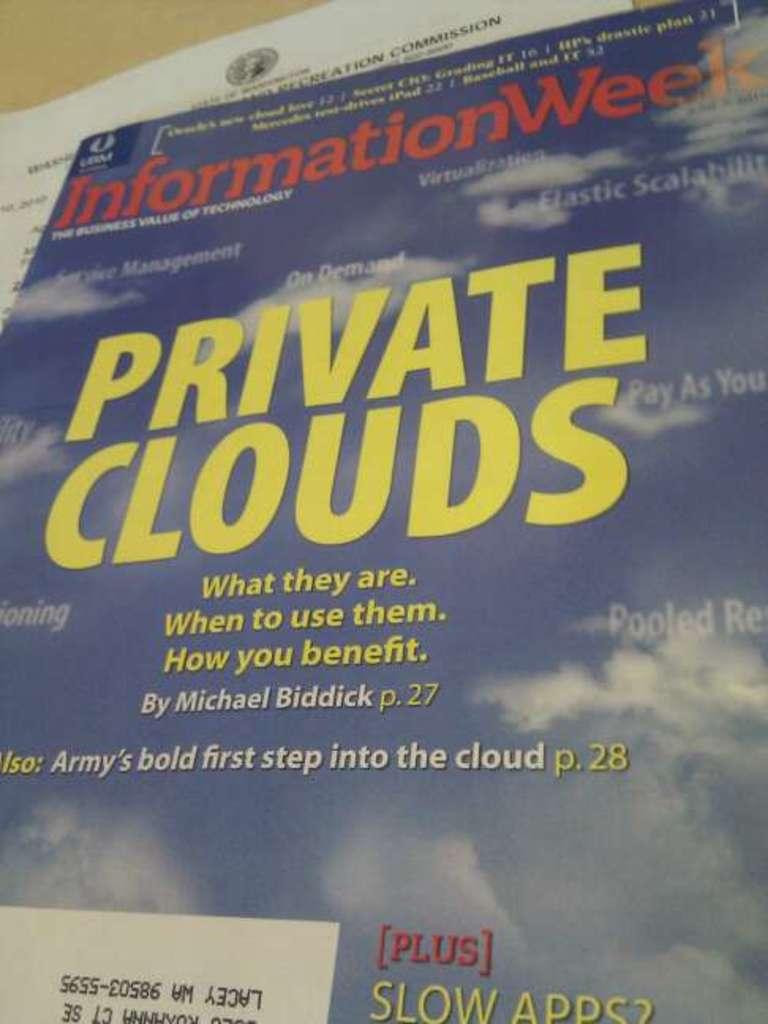What is the title of the magazine?
Your answer should be very brief. Information week. What kind of clouds?
Offer a terse response. Private. 